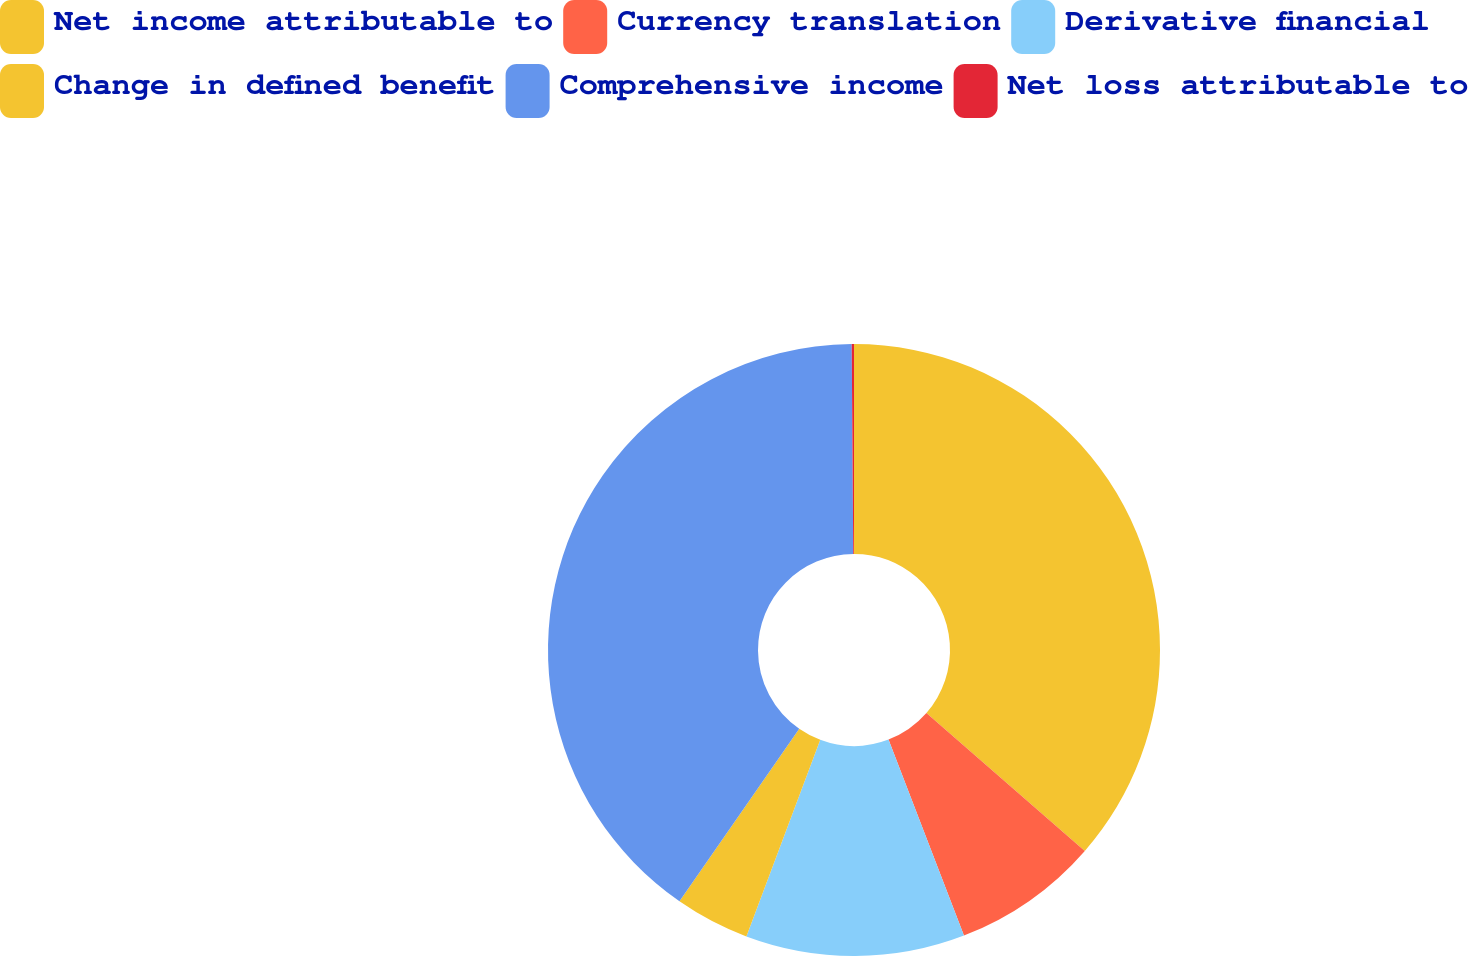Convert chart to OTSL. <chart><loc_0><loc_0><loc_500><loc_500><pie_chart><fcel>Net income attributable to<fcel>Currency translation<fcel>Derivative financial<fcel>Change in defined benefit<fcel>Comprehensive income<fcel>Net loss attributable to<nl><fcel>36.4%<fcel>7.75%<fcel>11.57%<fcel>3.94%<fcel>40.22%<fcel>0.12%<nl></chart> 